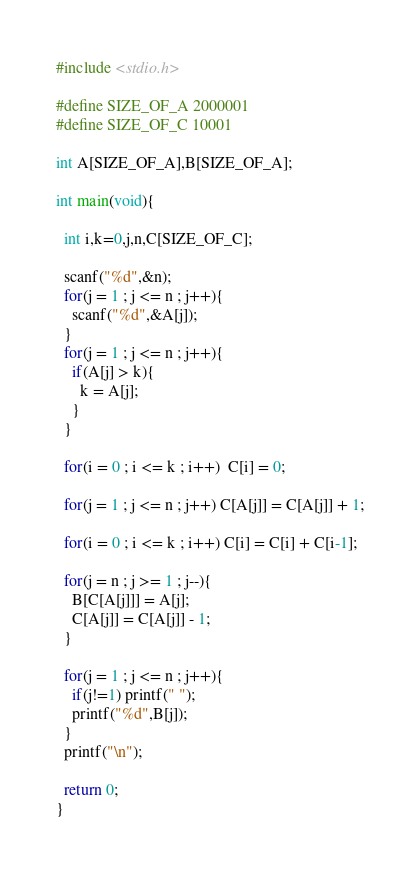Convert code to text. <code><loc_0><loc_0><loc_500><loc_500><_C_>#include <stdio.h>

#define SIZE_OF_A 2000001
#define SIZE_OF_C 10001

int A[SIZE_OF_A],B[SIZE_OF_A];

int main(void){ 
   
  int i,k=0,j,n,C[SIZE_OF_C];
 
  scanf("%d",&n);
  for(j = 1 ; j <= n ; j++){
    scanf("%d",&A[j]);
  }
  for(j = 1 ; j <= n ; j++){
    if(A[j] > k){   
      k = A[j];
    }
  }
   
  for(i = 0 ; i <= k ; i++)  C[i] = 0;
  
  for(j = 1 ; j <= n ; j++) C[A[j]] = C[A[j]] + 1;
   
  for(i = 0 ; i <= k ; i++) C[i] = C[i] + C[i-1];
   
  for(j = n ; j >= 1 ; j--){
    B[C[A[j]]] = A[j];
    C[A[j]] = C[A[j]] - 1;
  }

  for(j = 1 ; j <= n ; j++){
    if(j!=1) printf(" ");
    printf("%d",B[j]);
  }
  printf("\n");
   
  return 0;
}</code> 